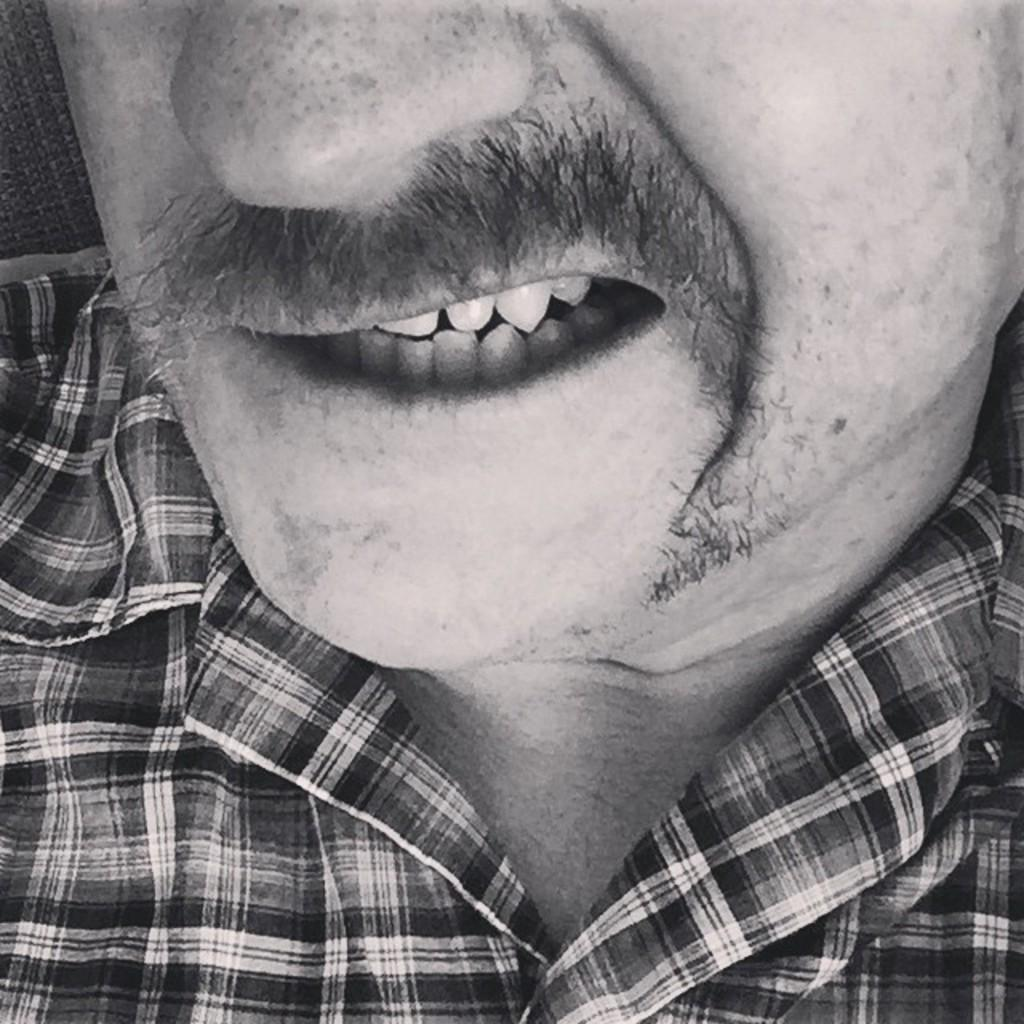What is the color scheme of the image? The image is black and white. What can be seen in the image? There is a man's face in the image. What is the man wearing in the image? The man is wearing a checkered shirt. Can you point out the zipper on the map in the image? There is no map or zipper present in the image; it features a man's face and a checkered shirt. 